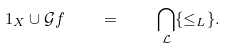Convert formula to latex. <formula><loc_0><loc_0><loc_500><loc_500>1 _ { X } \cup \mathcal { G } f \quad = \quad \bigcap _ { \mathcal { L } } \{ \leq _ { L } \} .</formula> 